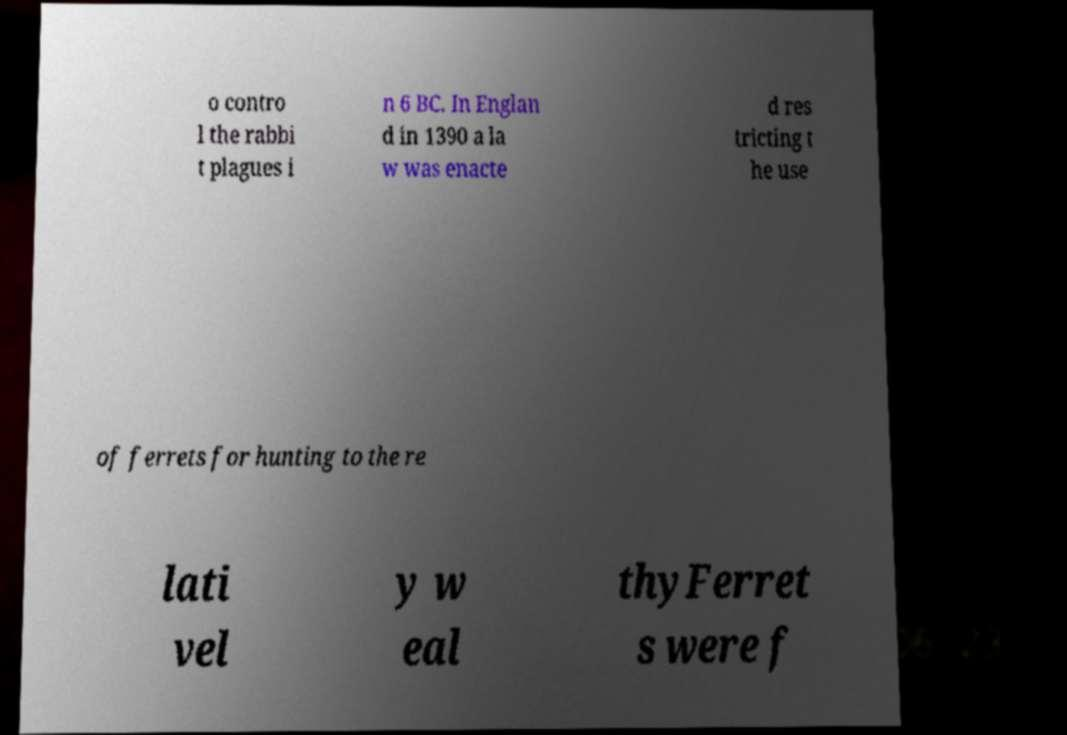Please read and relay the text visible in this image. What does it say? o contro l the rabbi t plagues i n 6 BC. In Englan d in 1390 a la w was enacte d res tricting t he use of ferrets for hunting to the re lati vel y w eal thyFerret s were f 